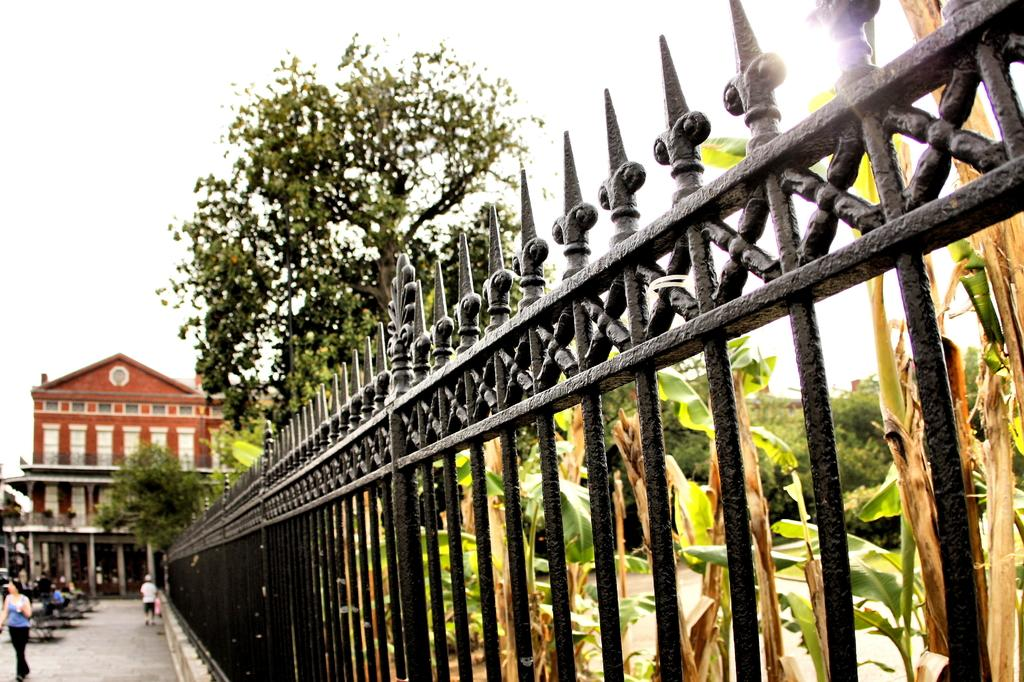What type of structure can be seen in the image? There is a railing in the image. What natural elements are present in the image? There are trees in the image. What man-made structure is visible in the image? There is a building in the image. What are the people in the image doing? There are persons walking on the road in the image. What can be seen in the background of the image? The sky is visible in the background of the image. What arithmetic problem is being solved by the trees in the image? There is no arithmetic problem being solved by the trees in the image; they are simply trees. How many rings are visible on the building in the image? There is no mention of rings on the building in the image; only the presence of a railing, trees, and a building is noted. 